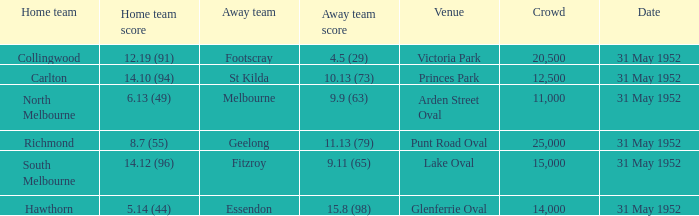When was the match when footscray was the visiting team? 31 May 1952. 